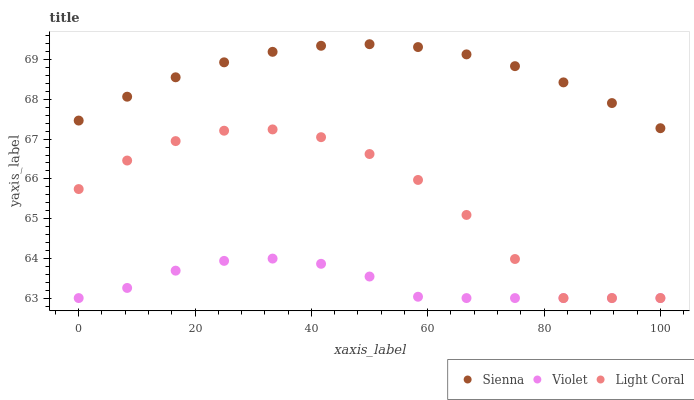Does Violet have the minimum area under the curve?
Answer yes or no. Yes. Does Sienna have the maximum area under the curve?
Answer yes or no. Yes. Does Light Coral have the minimum area under the curve?
Answer yes or no. No. Does Light Coral have the maximum area under the curve?
Answer yes or no. No. Is Sienna the smoothest?
Answer yes or no. Yes. Is Light Coral the roughest?
Answer yes or no. Yes. Is Violet the smoothest?
Answer yes or no. No. Is Violet the roughest?
Answer yes or no. No. Does Light Coral have the lowest value?
Answer yes or no. Yes. Does Sienna have the highest value?
Answer yes or no. Yes. Does Light Coral have the highest value?
Answer yes or no. No. Is Violet less than Sienna?
Answer yes or no. Yes. Is Sienna greater than Light Coral?
Answer yes or no. Yes. Does Light Coral intersect Violet?
Answer yes or no. Yes. Is Light Coral less than Violet?
Answer yes or no. No. Is Light Coral greater than Violet?
Answer yes or no. No. Does Violet intersect Sienna?
Answer yes or no. No. 